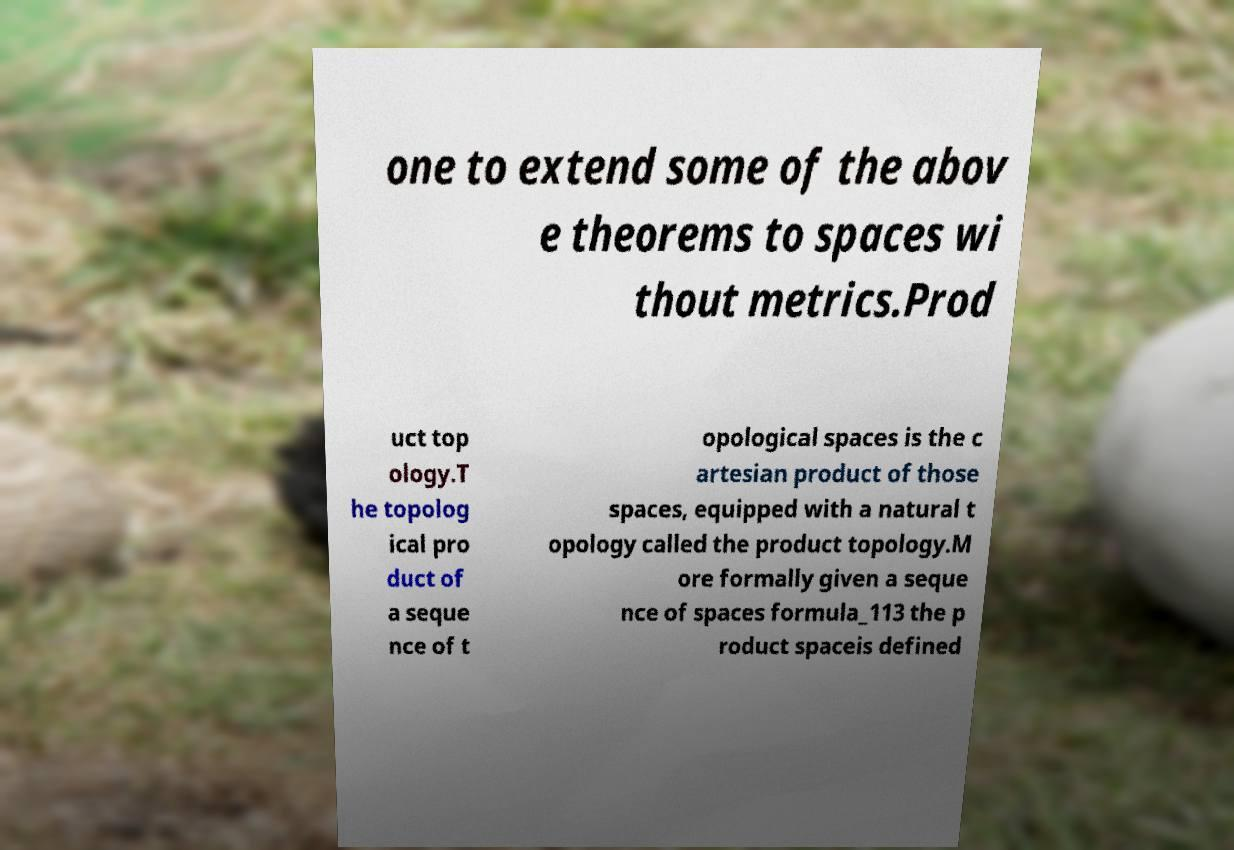Could you extract and type out the text from this image? one to extend some of the abov e theorems to spaces wi thout metrics.Prod uct top ology.T he topolog ical pro duct of a seque nce of t opological spaces is the c artesian product of those spaces, equipped with a natural t opology called the product topology.M ore formally given a seque nce of spaces formula_113 the p roduct spaceis defined 